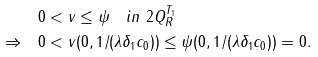<formula> <loc_0><loc_0><loc_500><loc_500>& 0 < v \leq \psi \quad i n \ 2 { Q _ { R } ^ { T _ { 1 } } } \\ \Rightarrow \quad & 0 < v ( 0 , 1 / ( \lambda \delta _ { 1 } c _ { 0 } ) ) \leq \psi ( 0 , 1 / ( \lambda \delta _ { 1 } c _ { 0 } ) ) = 0 .</formula> 